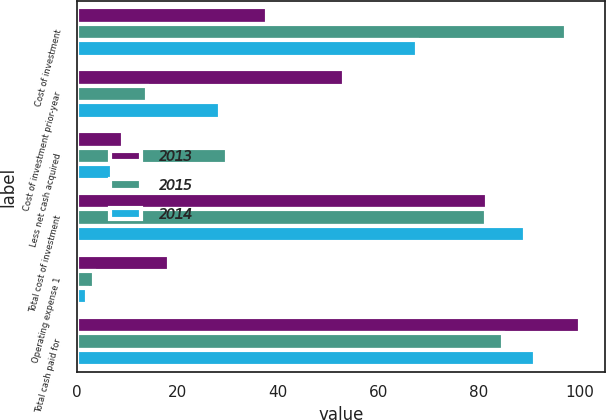Convert chart to OTSL. <chart><loc_0><loc_0><loc_500><loc_500><stacked_bar_chart><ecel><fcel>Cost of investment<fcel>Cost of investment prior-year<fcel>Less net cash acquired<fcel>Total cost of investment<fcel>Operating expense 1<fcel>Total cash paid for<nl><fcel>2013<fcel>37.8<fcel>53.1<fcel>9.2<fcel>81.7<fcel>18.4<fcel>100.1<nl><fcel>2015<fcel>97.3<fcel>14<fcel>29.9<fcel>81.4<fcel>3.4<fcel>84.8<nl><fcel>2014<fcel>67.7<fcel>28.5<fcel>7.1<fcel>89.1<fcel>2<fcel>91.1<nl></chart> 